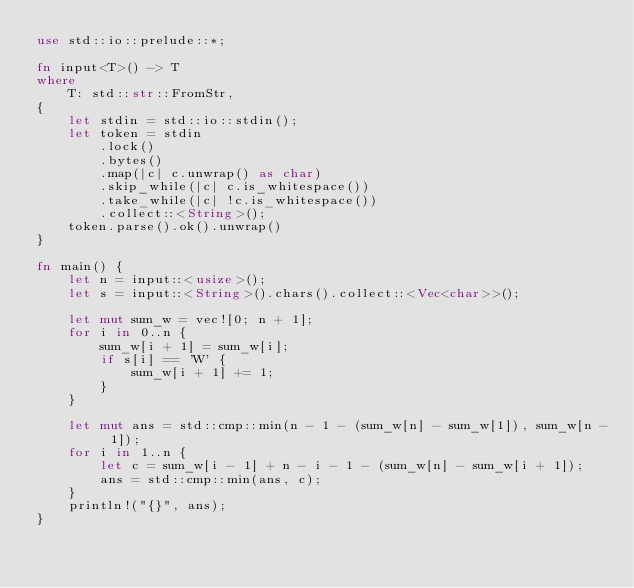<code> <loc_0><loc_0><loc_500><loc_500><_Rust_>use std::io::prelude::*;

fn input<T>() -> T
where
    T: std::str::FromStr,
{
    let stdin = std::io::stdin();
    let token = stdin
        .lock()
        .bytes()
        .map(|c| c.unwrap() as char)
        .skip_while(|c| c.is_whitespace())
        .take_while(|c| !c.is_whitespace())
        .collect::<String>();
    token.parse().ok().unwrap()
}

fn main() {
    let n = input::<usize>();
    let s = input::<String>().chars().collect::<Vec<char>>();

    let mut sum_w = vec![0; n + 1];
    for i in 0..n {
        sum_w[i + 1] = sum_w[i];
        if s[i] == 'W' {
            sum_w[i + 1] += 1;
        }
    }

    let mut ans = std::cmp::min(n - 1 - (sum_w[n] - sum_w[1]), sum_w[n - 1]);
    for i in 1..n {
        let c = sum_w[i - 1] + n - i - 1 - (sum_w[n] - sum_w[i + 1]);
        ans = std::cmp::min(ans, c);
    }
    println!("{}", ans);
}
</code> 